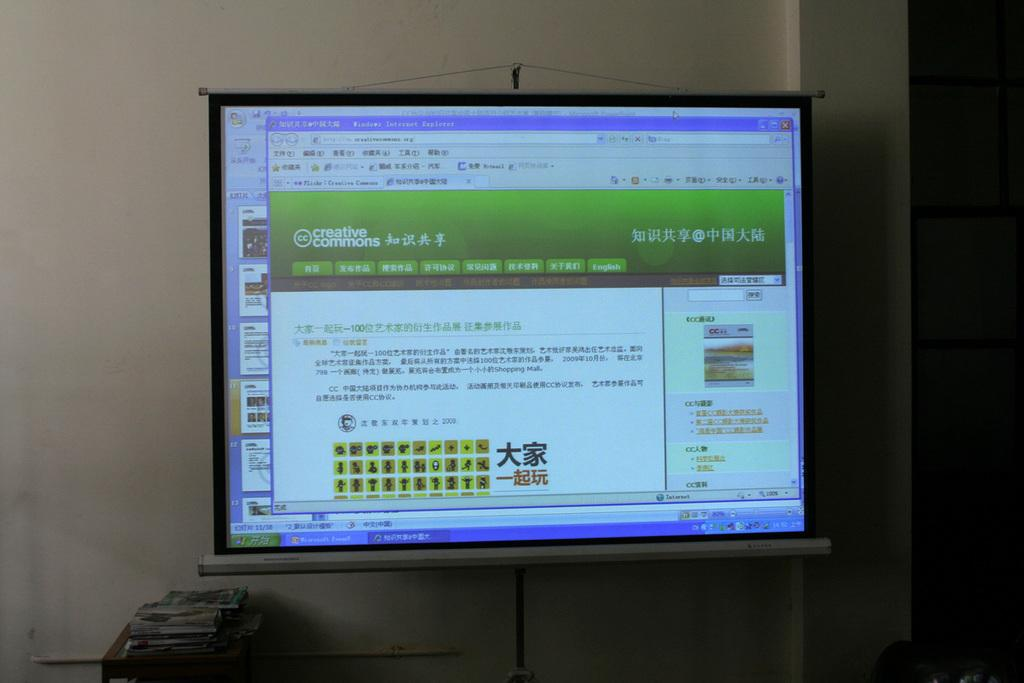<image>
Relay a brief, clear account of the picture shown. Computer screen open to a web page called Creative Commons. 